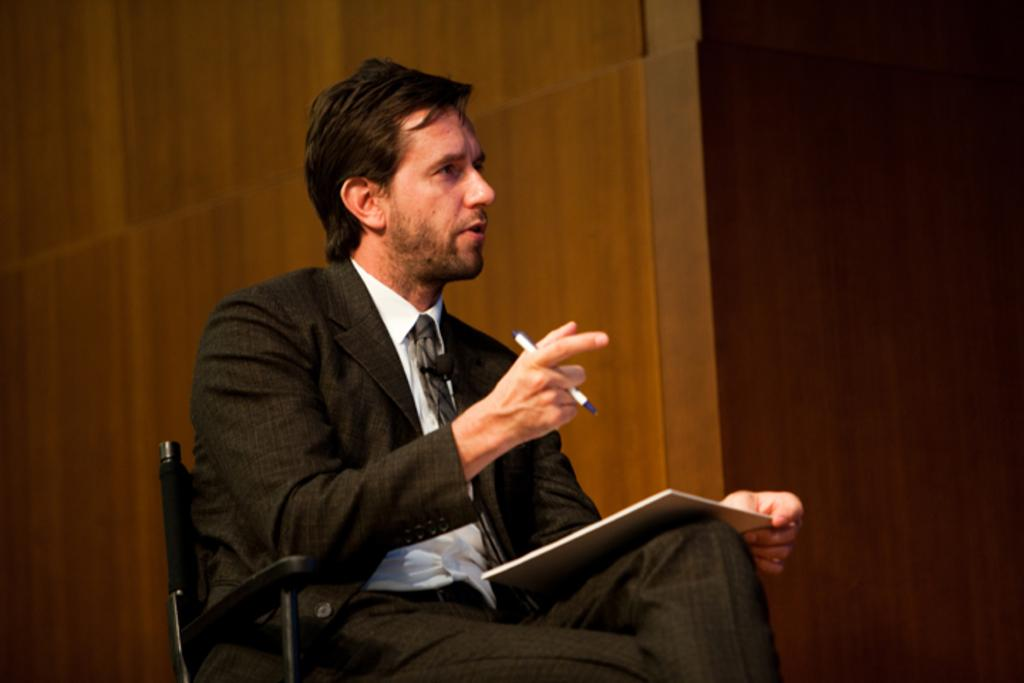What is the man in the image wearing? The man is wearing a white shirt, a black coat, and black pants. What is the man doing in the image? The man is sitting in a chair and holding a pad and a pen. What can be seen in the background of the image? There is a wooden wall in the background of the image. Where are the kittens playing in the image? There are no kittens present in the image. What type of stream can be seen flowing through the image? There is no stream present in the image. 